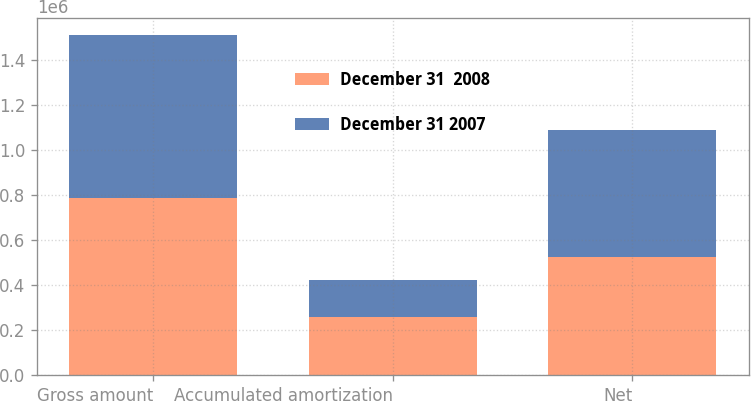Convert chart. <chart><loc_0><loc_0><loc_500><loc_500><stacked_bar_chart><ecel><fcel>Gross amount<fcel>Accumulated amortization<fcel>Net<nl><fcel>December 31  2008<fcel>784192<fcel>258242<fcel>525950<nl><fcel>December 31 2007<fcel>726204<fcel>162845<fcel>563359<nl></chart> 